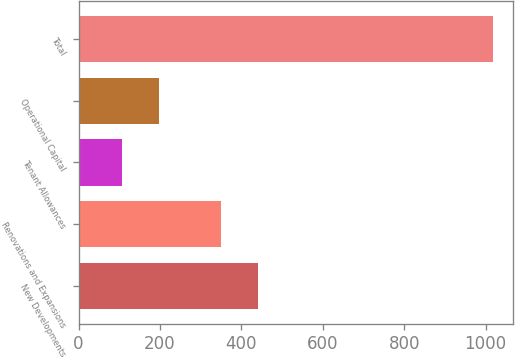<chart> <loc_0><loc_0><loc_500><loc_500><bar_chart><fcel>New Developments<fcel>Renovations and Expansions<fcel>Tenant Allowances<fcel>Operational Capital<fcel>Total<nl><fcel>440.1<fcel>349<fcel>106<fcel>197.1<fcel>1017<nl></chart> 